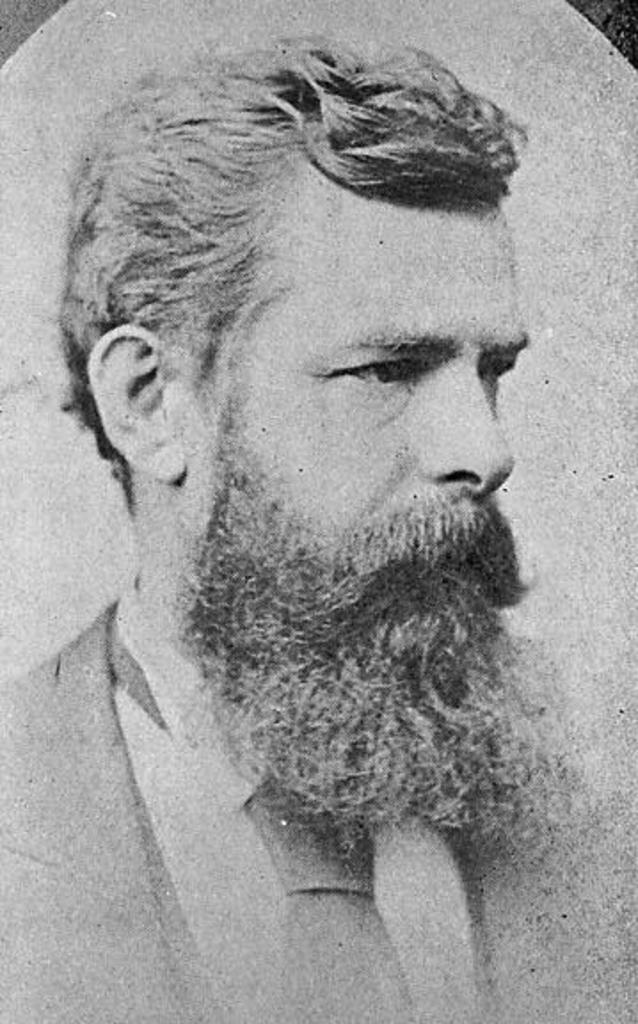What type of image is present in the picture? The image contains an old photograph. What color scheme is used in the photograph? The photograph is in black and white. Who is depicted in the photograph? The photograph depicts a man. What facial feature does the man have? The man has a long beard. What clothing items is the man wearing in the photograph? The man is wearing a blazer, a tie, and a shirt. What memory does the man have about his father in the image? The image does not provide any information about the man's memories or his relationship with his father. 